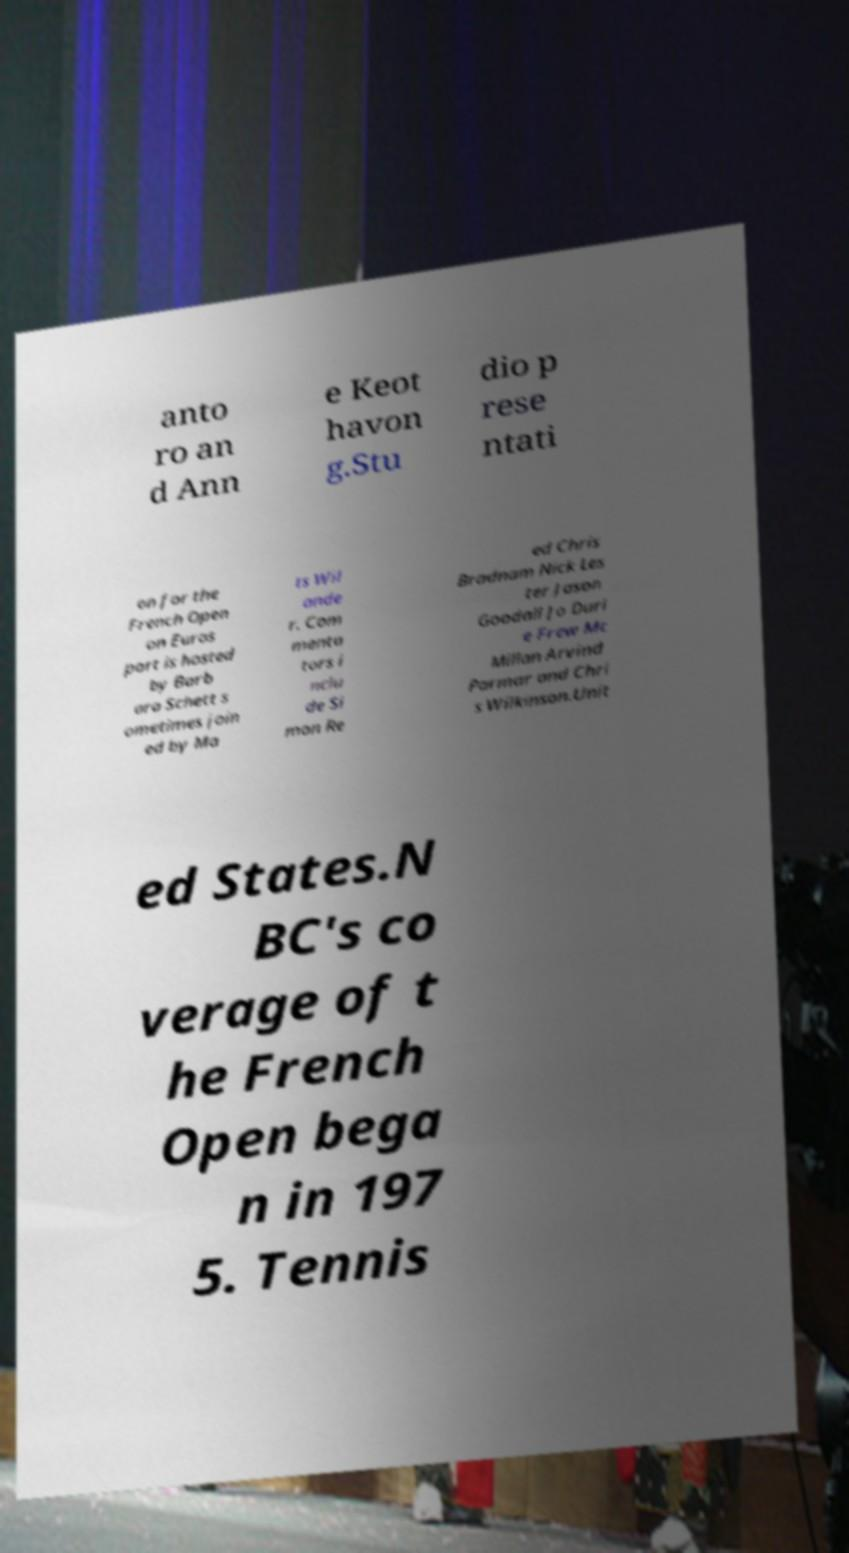For documentation purposes, I need the text within this image transcribed. Could you provide that? anto ro an d Ann e Keot havon g.Stu dio p rese ntati on for the French Open on Euros port is hosted by Barb ara Schett s ometimes join ed by Ma ts Wil ande r. Com menta tors i nclu de Si mon Re ed Chris Bradnam Nick Les ter Jason Goodall Jo Duri e Frew Mc Millan Arvind Parmar and Chri s Wilkinson.Unit ed States.N BC's co verage of t he French Open bega n in 197 5. Tennis 